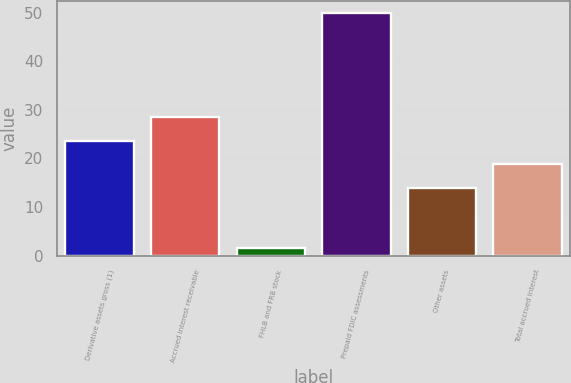Convert chart to OTSL. <chart><loc_0><loc_0><loc_500><loc_500><bar_chart><fcel>Derivative assets gross (1)<fcel>Accrued interest receivable<fcel>FHLB and FRB stock<fcel>Prepaid FDIC assessments<fcel>Other assets<fcel>Total accrued interest<nl><fcel>23.68<fcel>28.52<fcel>1.5<fcel>49.9<fcel>14<fcel>18.84<nl></chart> 